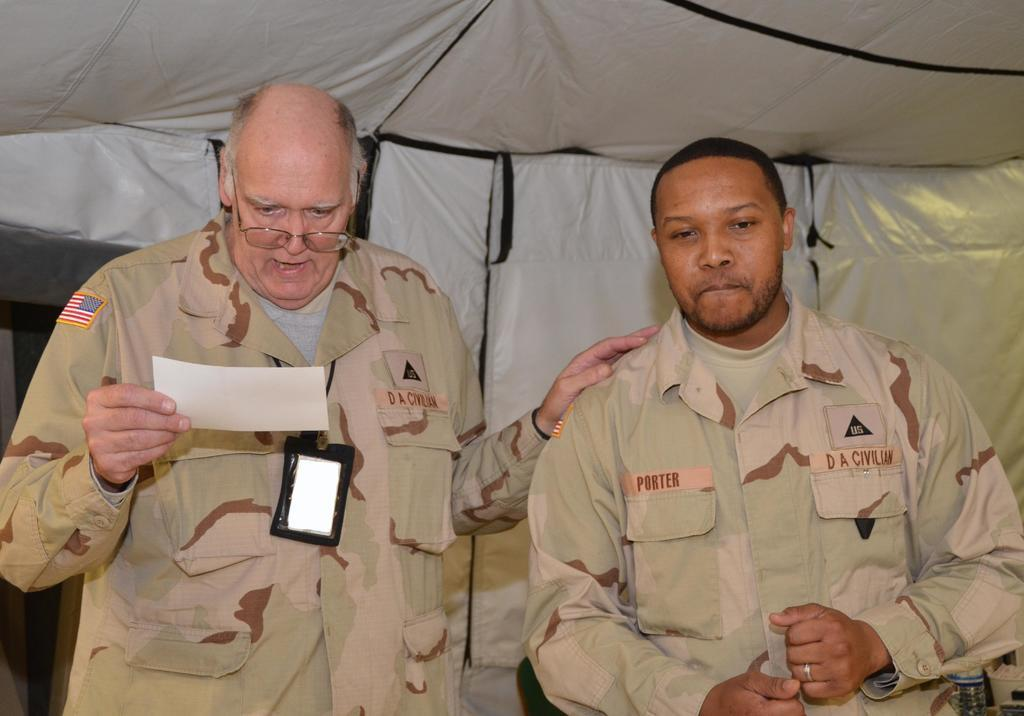How many people are in the image? There are two persons in the image. What is one of the persons holding? One of the persons is holding a paper. Where are the two persons located in the image? The two persons are under a tent. What color of paint is being used by the person on the left in the image? There is no paint or painting activity present in the image. What type of steel structure can be seen supporting the tent in the image? There is no steel structure visible in the image; only a tent is mentioned. 